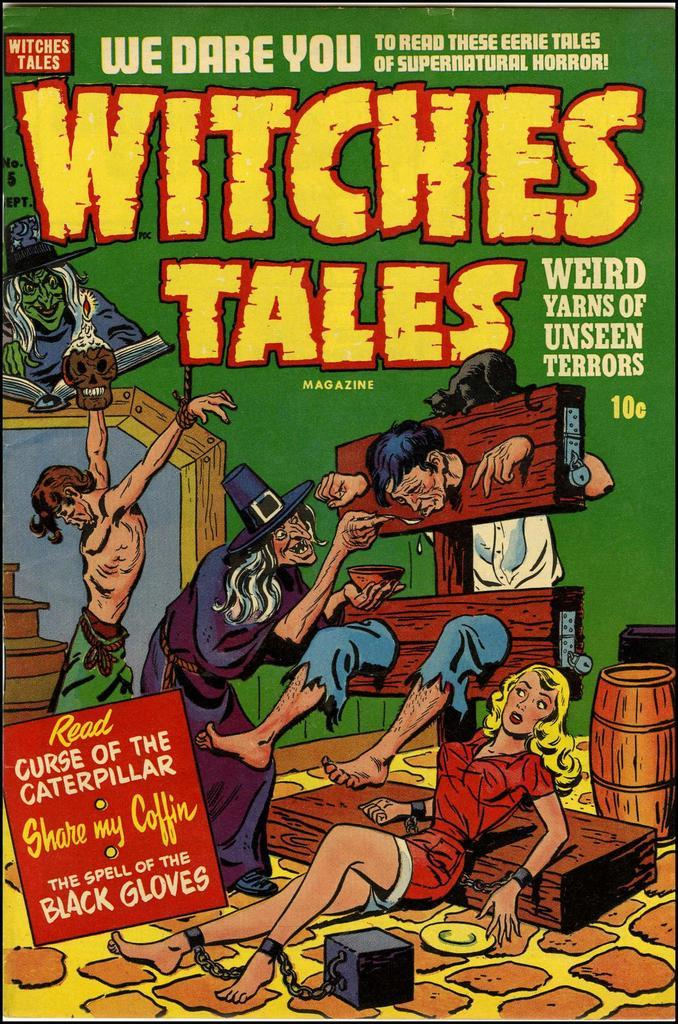<image>
Summarize the visual content of the image. An issue of Witches Tales magazine sold for 10 cents when it was new. 